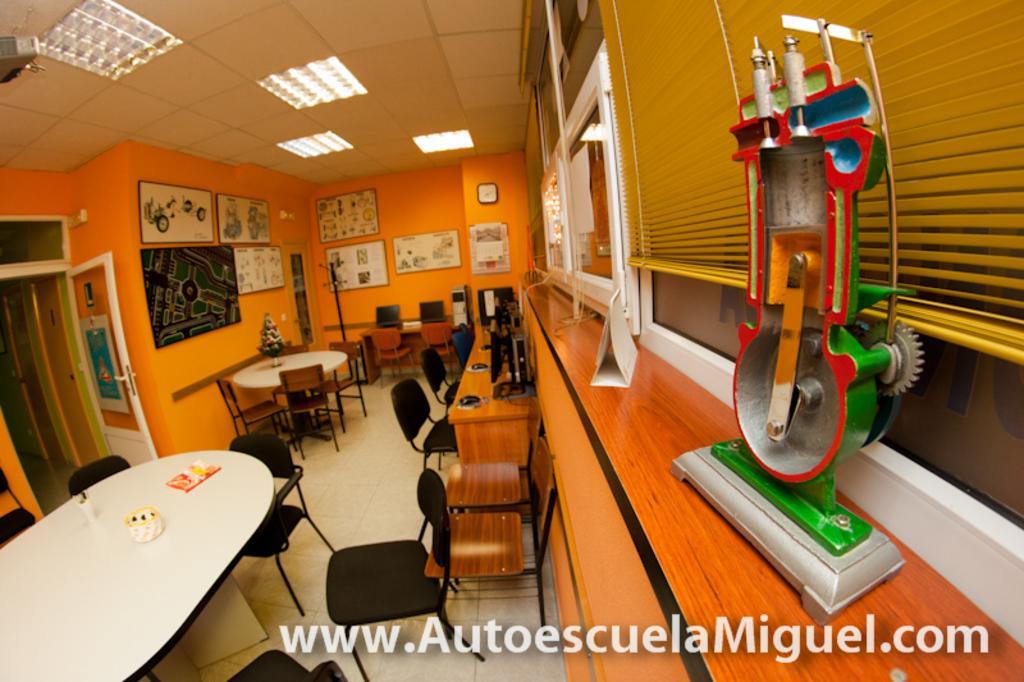Describe this image in one or two sentences. In this picture we can see closed room, we can see some tables, chairs, windows to the wall and some objects are placed on the table. 